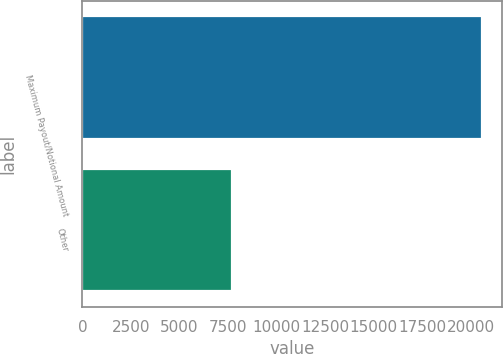<chart> <loc_0><loc_0><loc_500><loc_500><bar_chart><fcel>Maximum Payout/Notional Amount<fcel>Other<nl><fcel>20588<fcel>7712<nl></chart> 